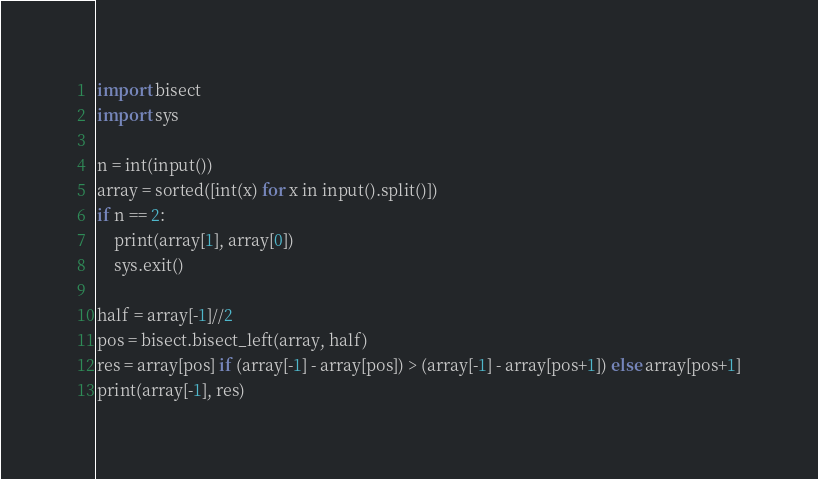Convert code to text. <code><loc_0><loc_0><loc_500><loc_500><_Python_>import bisect
import sys

n = int(input())
array = sorted([int(x) for x in input().split()])
if n == 2:
    print(array[1], array[0])
    sys.exit()

half = array[-1]//2
pos = bisect.bisect_left(array, half)
res = array[pos] if (array[-1] - array[pos]) > (array[-1] - array[pos+1]) else array[pos+1]
print(array[-1], res) </code> 